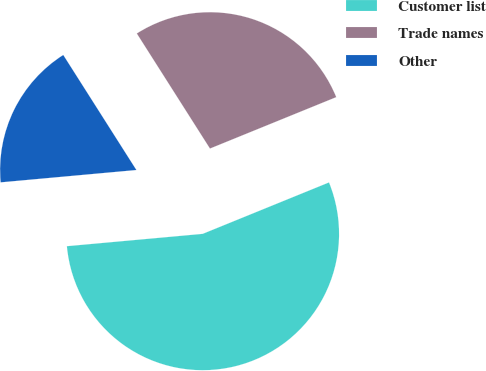<chart> <loc_0><loc_0><loc_500><loc_500><pie_chart><fcel>Customer list<fcel>Trade names<fcel>Other<nl><fcel>54.71%<fcel>27.86%<fcel>17.43%<nl></chart> 